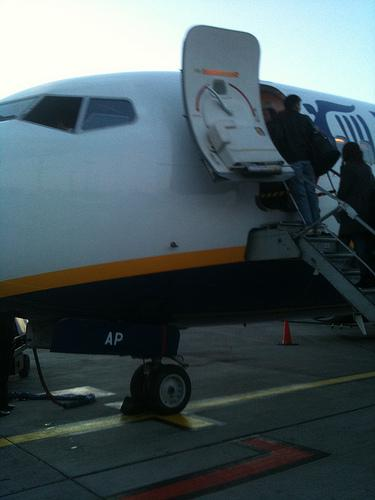Question: where is the airplane?
Choices:
A. Over Colorado.
B. On the runway.
C. At the airport.
D. By the gate.
Answer with the letter. Answer: C Question: what is open on the plane?
Choices:
A. The bar.
B. The cockpit.
C. The window.
D. The door.
Answer with the letter. Answer: D Question: why are people walking up the steps?
Choices:
A. To board the plane.
B. To go to the store.
C. To go to the restaurant.
D. To exit the building.
Answer with the letter. Answer: A Question: what color is the body of the plane?
Choices:
A. Silver.
B. White.
C. Black.
D. Red.
Answer with the letter. Answer: B Question: who drives a vehicle like this?
Choices:
A. A racecar driver.
B. A farmer.
C. A pilot.
D. A butler.
Answer with the letter. Answer: C 